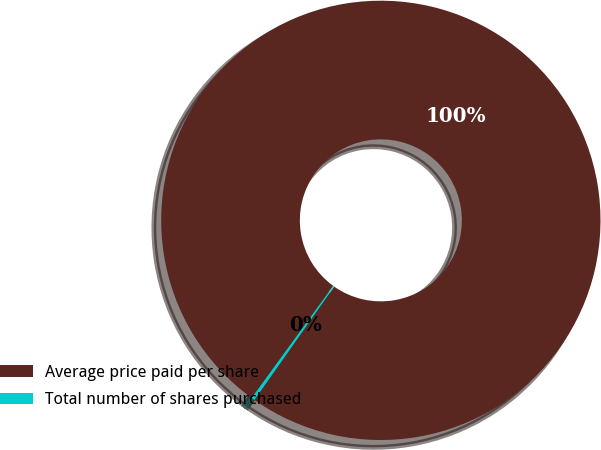<chart> <loc_0><loc_0><loc_500><loc_500><pie_chart><fcel>Average price paid per share<fcel>Total number of shares purchased<nl><fcel>99.76%<fcel>0.24%<nl></chart> 